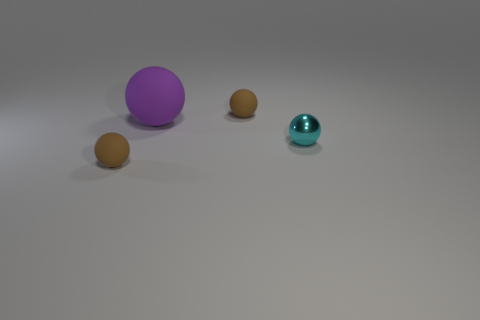Are there any other things that are the same size as the purple ball?
Your answer should be very brief. No. What number of other objects are there of the same material as the cyan object?
Your answer should be very brief. 0. Is the number of purple things greater than the number of tiny cylinders?
Your answer should be very brief. Yes. What is the color of the large rubber object?
Your response must be concise. Purple. Is there a metal sphere that is right of the matte thing that is behind the big purple object?
Your answer should be compact. Yes. There is a brown matte thing behind the thing in front of the cyan metallic sphere; what is its shape?
Keep it short and to the point. Sphere. Are there fewer shiny balls than large red matte cylinders?
Make the answer very short. No. What color is the small thing that is both to the right of the purple matte sphere and in front of the big thing?
Make the answer very short. Cyan. Is there a cyan metal ball that has the same size as the metallic object?
Your answer should be compact. No. What size is the brown ball behind the matte object that is in front of the cyan sphere?
Provide a short and direct response. Small. 